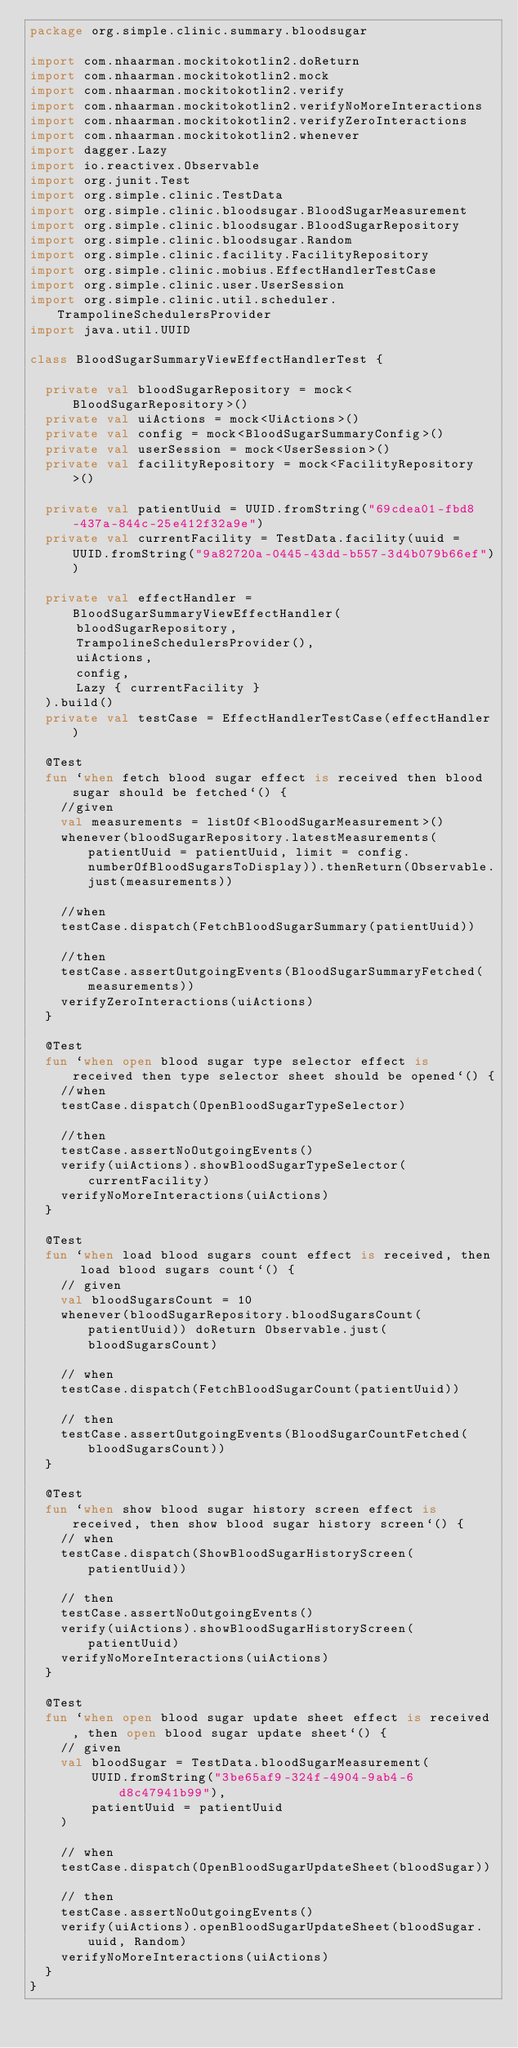<code> <loc_0><loc_0><loc_500><loc_500><_Kotlin_>package org.simple.clinic.summary.bloodsugar

import com.nhaarman.mockitokotlin2.doReturn
import com.nhaarman.mockitokotlin2.mock
import com.nhaarman.mockitokotlin2.verify
import com.nhaarman.mockitokotlin2.verifyNoMoreInteractions
import com.nhaarman.mockitokotlin2.verifyZeroInteractions
import com.nhaarman.mockitokotlin2.whenever
import dagger.Lazy
import io.reactivex.Observable
import org.junit.Test
import org.simple.clinic.TestData
import org.simple.clinic.bloodsugar.BloodSugarMeasurement
import org.simple.clinic.bloodsugar.BloodSugarRepository
import org.simple.clinic.bloodsugar.Random
import org.simple.clinic.facility.FacilityRepository
import org.simple.clinic.mobius.EffectHandlerTestCase
import org.simple.clinic.user.UserSession
import org.simple.clinic.util.scheduler.TrampolineSchedulersProvider
import java.util.UUID

class BloodSugarSummaryViewEffectHandlerTest {

  private val bloodSugarRepository = mock<BloodSugarRepository>()
  private val uiActions = mock<UiActions>()
  private val config = mock<BloodSugarSummaryConfig>()
  private val userSession = mock<UserSession>()
  private val facilityRepository = mock<FacilityRepository>()

  private val patientUuid = UUID.fromString("69cdea01-fbd8-437a-844c-25e412f32a9e")
  private val currentFacility = TestData.facility(uuid = UUID.fromString("9a82720a-0445-43dd-b557-3d4b079b66ef"))

  private val effectHandler = BloodSugarSummaryViewEffectHandler(
      bloodSugarRepository,
      TrampolineSchedulersProvider(),
      uiActions,
      config,
      Lazy { currentFacility }
  ).build()
  private val testCase = EffectHandlerTestCase(effectHandler)

  @Test
  fun `when fetch blood sugar effect is received then blood sugar should be fetched`() {
    //given
    val measurements = listOf<BloodSugarMeasurement>()
    whenever(bloodSugarRepository.latestMeasurements(patientUuid = patientUuid, limit = config.numberOfBloodSugarsToDisplay)).thenReturn(Observable.just(measurements))

    //when
    testCase.dispatch(FetchBloodSugarSummary(patientUuid))

    //then
    testCase.assertOutgoingEvents(BloodSugarSummaryFetched(measurements))
    verifyZeroInteractions(uiActions)
  }

  @Test
  fun `when open blood sugar type selector effect is received then type selector sheet should be opened`() {
    //when
    testCase.dispatch(OpenBloodSugarTypeSelector)

    //then
    testCase.assertNoOutgoingEvents()
    verify(uiActions).showBloodSugarTypeSelector(currentFacility)
    verifyNoMoreInteractions(uiActions)
  }

  @Test
  fun `when load blood sugars count effect is received, then load blood sugars count`() {
    // given
    val bloodSugarsCount = 10
    whenever(bloodSugarRepository.bloodSugarsCount(patientUuid)) doReturn Observable.just(bloodSugarsCount)

    // when
    testCase.dispatch(FetchBloodSugarCount(patientUuid))

    // then
    testCase.assertOutgoingEvents(BloodSugarCountFetched(bloodSugarsCount))
  }

  @Test
  fun `when show blood sugar history screen effect is received, then show blood sugar history screen`() {
    // when
    testCase.dispatch(ShowBloodSugarHistoryScreen(patientUuid))

    // then
    testCase.assertNoOutgoingEvents()
    verify(uiActions).showBloodSugarHistoryScreen(patientUuid)
    verifyNoMoreInteractions(uiActions)
  }

  @Test
  fun `when open blood sugar update sheet effect is received, then open blood sugar update sheet`() {
    // given
    val bloodSugar = TestData.bloodSugarMeasurement(
        UUID.fromString("3be65af9-324f-4904-9ab4-6d8c47941b99"),
        patientUuid = patientUuid
    )

    // when
    testCase.dispatch(OpenBloodSugarUpdateSheet(bloodSugar))

    // then
    testCase.assertNoOutgoingEvents()
    verify(uiActions).openBloodSugarUpdateSheet(bloodSugar.uuid, Random)
    verifyNoMoreInteractions(uiActions)
  }
}
</code> 